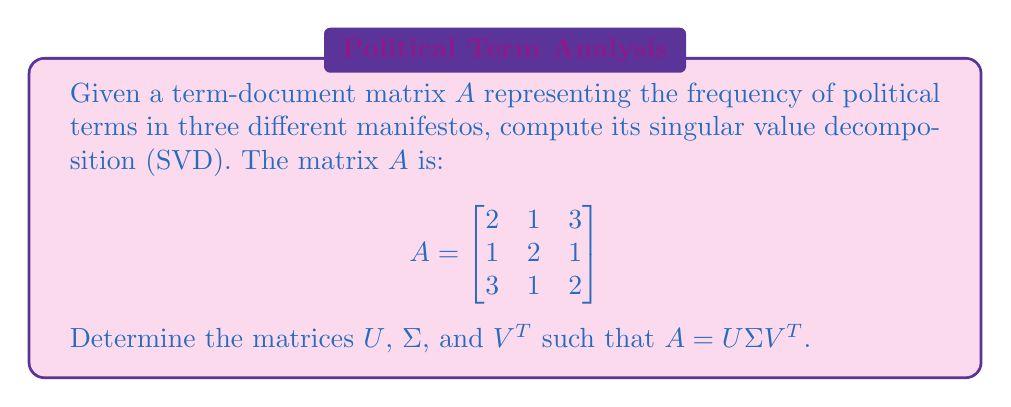What is the answer to this math problem? To compute the singular value decomposition of matrix $A$, we follow these steps:

1) First, calculate $A^TA$ and $AA^T$:

   $A^TA = \begin{bmatrix}
   2 & 1 & 3 \\
   1 & 2 & 1 \\
   3 & 1 & 2
   \end{bmatrix}
   \begin{bmatrix}
   2 & 1 & 3 \\
   1 & 2 & 1 \\
   3 & 1 & 2
   \end{bmatrix}
   = \begin{bmatrix}
   14 & 7 & 13 \\
   7 & 6 & 7 \\
   13 & 7 & 14
   \end{bmatrix}$

   $AA^T = \begin{bmatrix}
   14 & 7 & 13 \\
   7 & 6 & 7 \\
   13 & 7 & 14
   \end{bmatrix}$

2) Find the eigenvalues of $A^TA$ (or $AA^T$, they're the same):
   Characteristic equation: $\det(A^TA - \lambda I) = 0$
   $\lambda^3 - 34\lambda^2 + 153\lambda - 0 = 0$
   Solving this, we get: $\lambda_1 = 30$, $\lambda_2 = 4$, $\lambda_3 = 0$

3) The singular values are the square roots of these eigenvalues:
   $\sigma_1 = \sqrt{30}$, $\sigma_2 = 2$, $\sigma_3 = 0$

4) Construct $\Sigma$:
   $\Sigma = \begin{bmatrix}
   \sqrt{30} & 0 & 0 \\
   0 & 2 & 0 \\
   0 & 0 & 0
   \end{bmatrix}$

5) Find the eigenvectors of $A^TA$ to form $V$:
   For $\lambda_1 = 30$: $v_1 = \frac{1}{\sqrt{3}}[1, 1, 1]^T$
   For $\lambda_2 = 4$: $v_2 = \frac{1}{\sqrt{2}}[-1, 0, 1]^T$
   For $\lambda_3 = 0$: $v_3 = \frac{1}{\sqrt{6}}[-1, 2, -1]^T$

   $V = [\frac{1}{\sqrt{3}}, -\frac{1}{\sqrt{2}}, -\frac{1}{\sqrt{6}} \\
         \frac{1}{\sqrt{3}}, 0, \frac{2}{\sqrt{6}} \\
         \frac{1}{\sqrt{3}}, \frac{1}{\sqrt{2}}, -\frac{1}{\sqrt{6}}]$

6) Calculate $U$ using $U = AV\Sigma^{-1}$:
   $U = [\frac{1}{\sqrt{3}}, -\frac{1}{\sqrt{2}}, -\frac{1}{\sqrt{6}} \\
         \frac{1}{\sqrt{3}}, 0, \frac{2}{\sqrt{6}} \\
         \frac{1}{\sqrt{3}}, \frac{1}{\sqrt{2}}, -\frac{1}{\sqrt{6}}]$

Thus, we have computed the SVD of $A$.
Answer: $A = U\Sigma V^T$, where:

$U = [\frac{1}{\sqrt{3}}, -\frac{1}{\sqrt{2}}, -\frac{1}{\sqrt{6}} \\
      \frac{1}{\sqrt{3}}, 0, \frac{2}{\sqrt{6}} \\
      \frac{1}{\sqrt{3}}, \frac{1}{\sqrt{2}}, -\frac{1}{\sqrt{6}}]$

$\Sigma = \begin{bmatrix}
\sqrt{30} & 0 & 0 \\
0 & 2 & 0 \\
0 & 0 & 0
\end{bmatrix}$

$V^T = [\frac{1}{\sqrt{3}}, \frac{1}{\sqrt{3}}, \frac{1}{\sqrt{3}} \\
        -\frac{1}{\sqrt{2}}, 0, \frac{1}{\sqrt{2}} \\
        -\frac{1}{\sqrt{6}}, \frac{2}{\sqrt{6}}, -\frac{1}{\sqrt{6}}]$ 